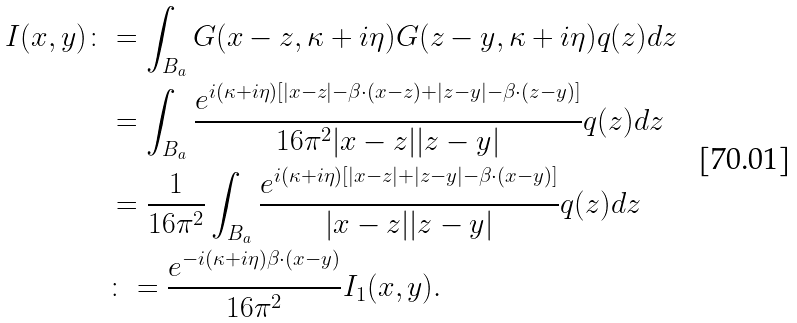<formula> <loc_0><loc_0><loc_500><loc_500>I ( x , y ) \colon & = \int _ { B _ { a } } G ( x - z , \kappa + i \eta ) G ( z - y , \kappa + i \eta ) q ( z ) d z \\ & = \int _ { B _ { a } } \frac { e ^ { i ( \kappa + i \eta ) [ | x - z | - \beta \cdot ( x - z ) + | z - y | - \beta \cdot ( z - y ) ] } } { 1 6 \pi ^ { 2 } | x - z | | z - y | } q ( z ) d z \\ & = \frac { 1 } { 1 6 \pi ^ { 2 } } \int _ { B _ { a } } \frac { e ^ { i ( \kappa + i \eta ) [ | x - z | + | z - y | - \beta \cdot ( x - y ) ] } } { | x - z | | z - y | } q ( z ) d z \\ & \colon = \frac { e ^ { - i ( \kappa + i \eta ) \beta \cdot ( x - y ) } } { 1 6 \pi ^ { 2 } } I _ { 1 } ( x , y ) . \\</formula> 